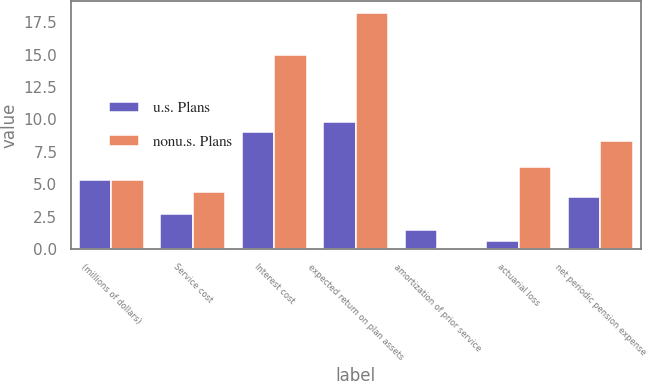Convert chart to OTSL. <chart><loc_0><loc_0><loc_500><loc_500><stacked_bar_chart><ecel><fcel>(millions of dollars)<fcel>Service cost<fcel>Interest cost<fcel>expected return on plan assets<fcel>amortization of prior service<fcel>actuarial loss<fcel>net periodic pension expense<nl><fcel>u.s. Plans<fcel>5.35<fcel>2.7<fcel>9<fcel>9.8<fcel>1.5<fcel>0.6<fcel>4<nl><fcel>nonu.s. Plans<fcel>5.35<fcel>4.4<fcel>15<fcel>18.2<fcel>0.1<fcel>6.3<fcel>8.3<nl></chart> 